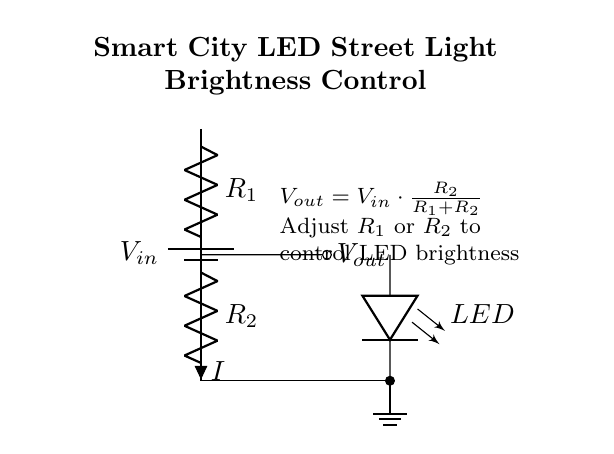What is the input voltage in this circuit? The input voltage is labeled as V_in in the circuit diagram. It represents the voltage supplied to the circuit from the battery.
Answer: V_in What are the two resistors in the voltage divider? The resistors are labeled R_1 and R_2 in the diagram. They are connected in series within the voltage divider configuration.
Answer: R_1 and R_2 What is the purpose of R_2 in this circuit? R_2 is part of the voltage divider and it determines the output voltage, V_out, when combined with R_1. Its value affects how much voltage is dropped across the LED.
Answer: Determine V_out How is the output voltage calculated? The output voltage V_out is calculated using the formula V_out = V_in * (R_2 / (R_1 + R_2)), which shows the ratio of R_2 to the total resistance in the divider.
Answer: V_out = V_in * (R_2 / (R_1 + R_2)) What effect does increasing R_1 have on the LED brightness? Increasing R_1 increases the total resistance in the voltage divider, which decreases the output voltage V_out and consequently reduces the brightness of the LED.
Answer: Decreases brightness What component is used to indicate output voltage visually? The LED serves as the visual indicator of the output voltage and its brightness represents the level of output voltage from the divider.
Answer: LED Which part of the circuit will control the LED's brightness specifically? The components that control the LED's brightness are the resistors R_1 and R_2, as they define the voltage division and the resultant V_out.
Answer: R_1 and R_2 